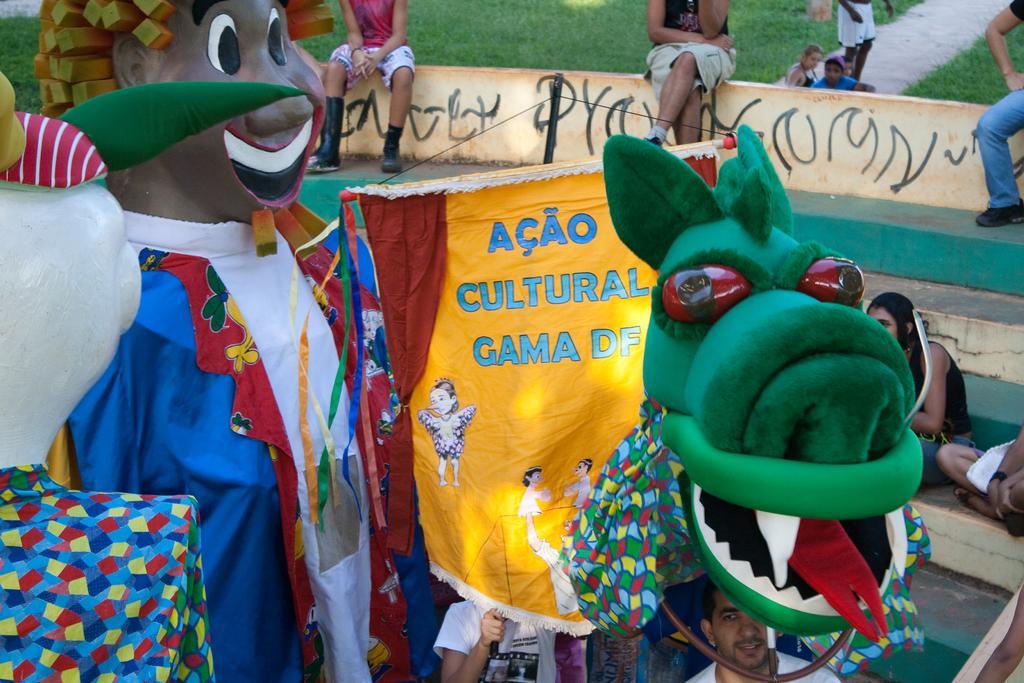How would you summarize this image in a sentence or two? In this picture we can see the people, grass, pathway, stairs, objects and costumes. We can see there is something written on the wall. 